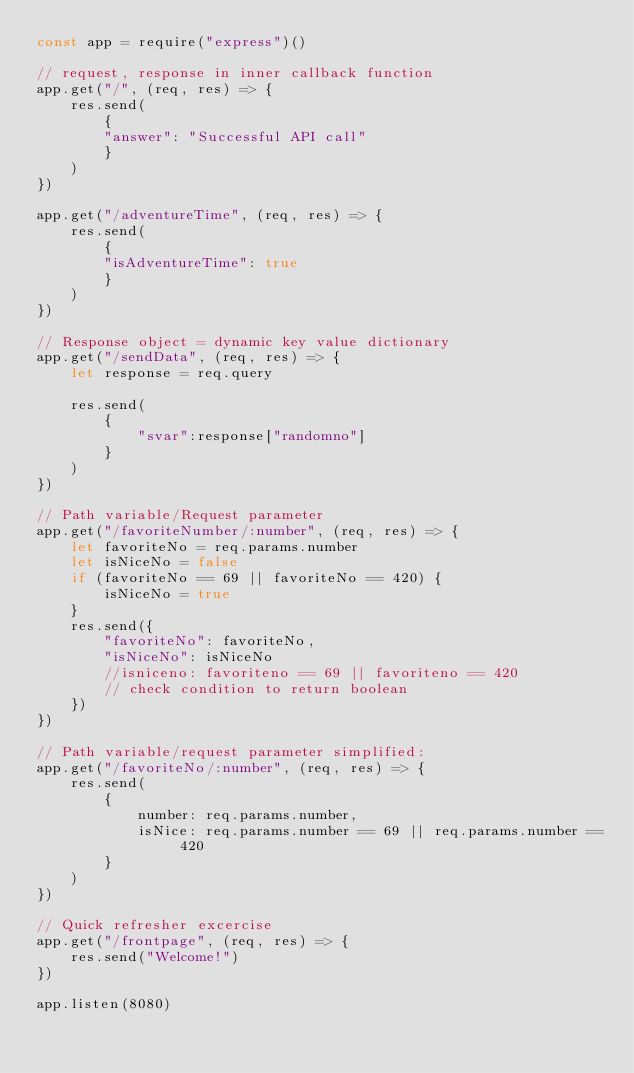<code> <loc_0><loc_0><loc_500><loc_500><_JavaScript_>const app = require("express")()

// request, response in inner callback function
app.get("/", (req, res) => {
    res.send(
        {
        "answer": "Successful API call"
        }
    )
})

app.get("/adventureTime", (req, res) => {
    res.send(
        {
        "isAdventureTime": true
        }
    )
})

// Response object = dynamic key value dictionary
app.get("/sendData", (req, res) => {
    let response = req.query
    
    res.send(
        {
            "svar":response["randomno"]
        }
    )
})

// Path variable/Request parameter
app.get("/favoriteNumber/:number", (req, res) => {
    let favoriteNo = req.params.number
    let isNiceNo = false
    if (favoriteNo == 69 || favoriteNo == 420) {
        isNiceNo = true
    }
    res.send({
        "favoriteNo": favoriteNo,
        "isNiceNo": isNiceNo
        //isniceno: favoriteno == 69 || favoriteno == 420
        // check condition to return boolean
    })
})

// Path variable/request parameter simplified:
app.get("/favoriteNo/:number", (req, res) => {
    res.send(
        {
            number: req.params.number,
            isNice: req.params.number == 69 || req.params.number == 420
        }
    )
})

// Quick refresher excercise
app.get("/frontpage", (req, res) => {
    res.send("Welcome!")
})

app.listen(8080)</code> 